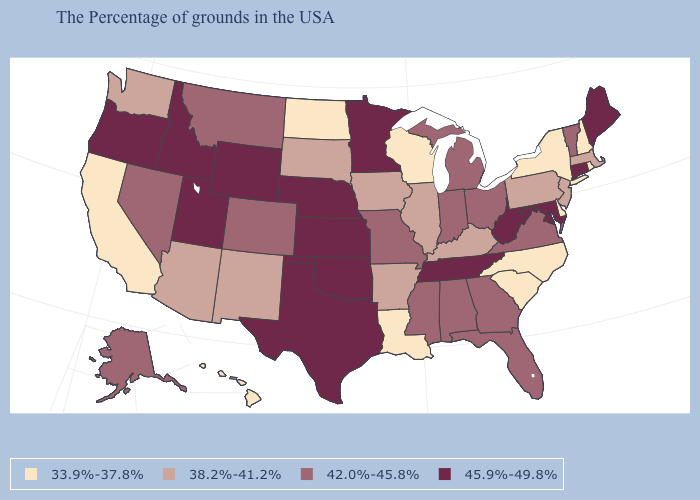Does the first symbol in the legend represent the smallest category?
Write a very short answer. Yes. Name the states that have a value in the range 33.9%-37.8%?
Short answer required. Rhode Island, New Hampshire, New York, Delaware, North Carolina, South Carolina, Wisconsin, Louisiana, North Dakota, California, Hawaii. Which states have the highest value in the USA?
Be succinct. Maine, Connecticut, Maryland, West Virginia, Tennessee, Minnesota, Kansas, Nebraska, Oklahoma, Texas, Wyoming, Utah, Idaho, Oregon. What is the value of Virginia?
Answer briefly. 42.0%-45.8%. Does Nevada have the lowest value in the West?
Answer briefly. No. Does Arizona have a higher value than Virginia?
Be succinct. No. Name the states that have a value in the range 38.2%-41.2%?
Give a very brief answer. Massachusetts, New Jersey, Pennsylvania, Kentucky, Illinois, Arkansas, Iowa, South Dakota, New Mexico, Arizona, Washington. Does Louisiana have the highest value in the USA?
Concise answer only. No. Does Washington have the same value as Minnesota?
Short answer required. No. What is the highest value in the West ?
Write a very short answer. 45.9%-49.8%. Name the states that have a value in the range 38.2%-41.2%?
Concise answer only. Massachusetts, New Jersey, Pennsylvania, Kentucky, Illinois, Arkansas, Iowa, South Dakota, New Mexico, Arizona, Washington. What is the value of Missouri?
Short answer required. 42.0%-45.8%. What is the value of Wyoming?
Be succinct. 45.9%-49.8%. Name the states that have a value in the range 38.2%-41.2%?
Be succinct. Massachusetts, New Jersey, Pennsylvania, Kentucky, Illinois, Arkansas, Iowa, South Dakota, New Mexico, Arizona, Washington. Among the states that border Connecticut , which have the lowest value?
Answer briefly. Rhode Island, New York. 